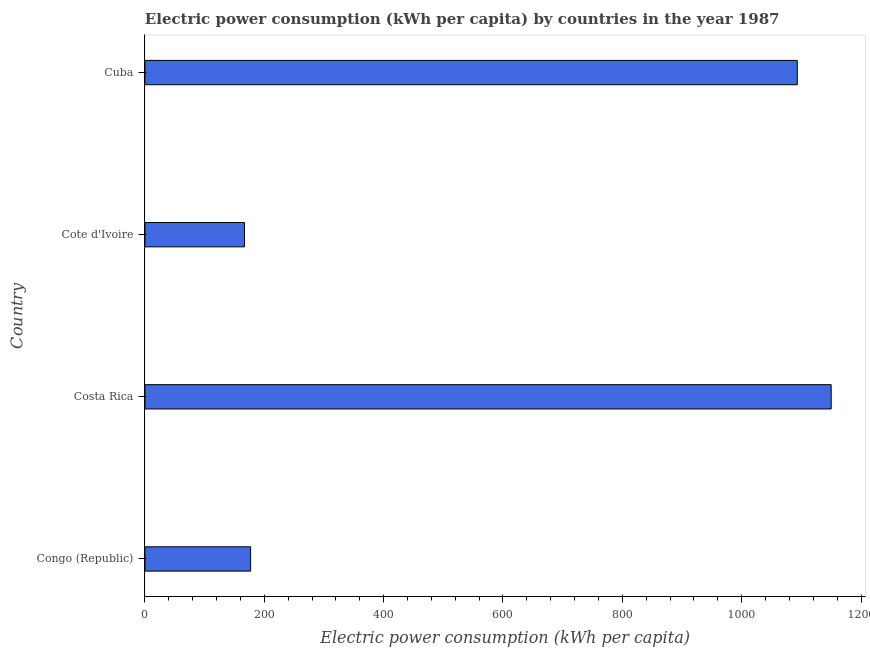Does the graph contain grids?
Provide a succinct answer. No. What is the title of the graph?
Your response must be concise. Electric power consumption (kWh per capita) by countries in the year 1987. What is the label or title of the X-axis?
Your response must be concise. Electric power consumption (kWh per capita). What is the label or title of the Y-axis?
Provide a short and direct response. Country. What is the electric power consumption in Congo (Republic)?
Your response must be concise. 177.1. Across all countries, what is the maximum electric power consumption?
Provide a short and direct response. 1149.98. Across all countries, what is the minimum electric power consumption?
Your answer should be very brief. 166.82. In which country was the electric power consumption minimum?
Your answer should be very brief. Cote d'Ivoire. What is the sum of the electric power consumption?
Provide a succinct answer. 2587.07. What is the difference between the electric power consumption in Cote d'Ivoire and Cuba?
Keep it short and to the point. -926.35. What is the average electric power consumption per country?
Provide a short and direct response. 646.77. What is the median electric power consumption?
Your response must be concise. 635.13. In how many countries, is the electric power consumption greater than 200 kWh per capita?
Provide a succinct answer. 2. What is the ratio of the electric power consumption in Congo (Republic) to that in Costa Rica?
Your answer should be very brief. 0.15. Is the electric power consumption in Costa Rica less than that in Cote d'Ivoire?
Offer a terse response. No. What is the difference between the highest and the second highest electric power consumption?
Your response must be concise. 56.82. Is the sum of the electric power consumption in Costa Rica and Cote d'Ivoire greater than the maximum electric power consumption across all countries?
Provide a short and direct response. Yes. What is the difference between the highest and the lowest electric power consumption?
Make the answer very short. 983.16. In how many countries, is the electric power consumption greater than the average electric power consumption taken over all countries?
Offer a very short reply. 2. Are all the bars in the graph horizontal?
Your answer should be compact. Yes. What is the difference between two consecutive major ticks on the X-axis?
Provide a succinct answer. 200. Are the values on the major ticks of X-axis written in scientific E-notation?
Offer a very short reply. No. What is the Electric power consumption (kWh per capita) in Congo (Republic)?
Your answer should be very brief. 177.1. What is the Electric power consumption (kWh per capita) of Costa Rica?
Provide a short and direct response. 1149.98. What is the Electric power consumption (kWh per capita) in Cote d'Ivoire?
Make the answer very short. 166.82. What is the Electric power consumption (kWh per capita) in Cuba?
Your answer should be very brief. 1093.16. What is the difference between the Electric power consumption (kWh per capita) in Congo (Republic) and Costa Rica?
Make the answer very short. -972.88. What is the difference between the Electric power consumption (kWh per capita) in Congo (Republic) and Cote d'Ivoire?
Keep it short and to the point. 10.28. What is the difference between the Electric power consumption (kWh per capita) in Congo (Republic) and Cuba?
Make the answer very short. -916.06. What is the difference between the Electric power consumption (kWh per capita) in Costa Rica and Cote d'Ivoire?
Ensure brevity in your answer.  983.16. What is the difference between the Electric power consumption (kWh per capita) in Costa Rica and Cuba?
Ensure brevity in your answer.  56.82. What is the difference between the Electric power consumption (kWh per capita) in Cote d'Ivoire and Cuba?
Provide a short and direct response. -926.34. What is the ratio of the Electric power consumption (kWh per capita) in Congo (Republic) to that in Costa Rica?
Offer a very short reply. 0.15. What is the ratio of the Electric power consumption (kWh per capita) in Congo (Republic) to that in Cote d'Ivoire?
Provide a succinct answer. 1.06. What is the ratio of the Electric power consumption (kWh per capita) in Congo (Republic) to that in Cuba?
Make the answer very short. 0.16. What is the ratio of the Electric power consumption (kWh per capita) in Costa Rica to that in Cote d'Ivoire?
Your response must be concise. 6.89. What is the ratio of the Electric power consumption (kWh per capita) in Costa Rica to that in Cuba?
Offer a very short reply. 1.05. What is the ratio of the Electric power consumption (kWh per capita) in Cote d'Ivoire to that in Cuba?
Offer a terse response. 0.15. 